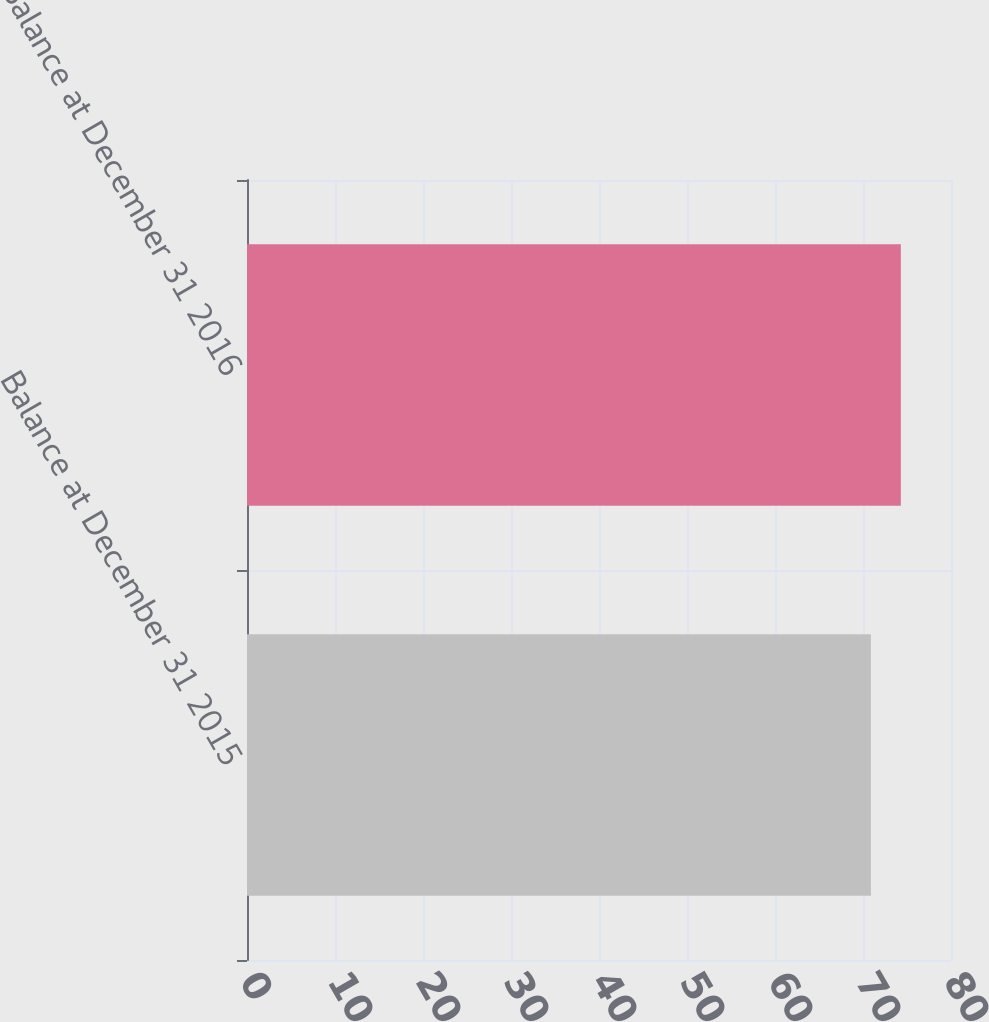Convert chart. <chart><loc_0><loc_0><loc_500><loc_500><bar_chart><fcel>Balance at December 31 2015<fcel>Balance at December 31 2016<nl><fcel>70.9<fcel>74.3<nl></chart> 